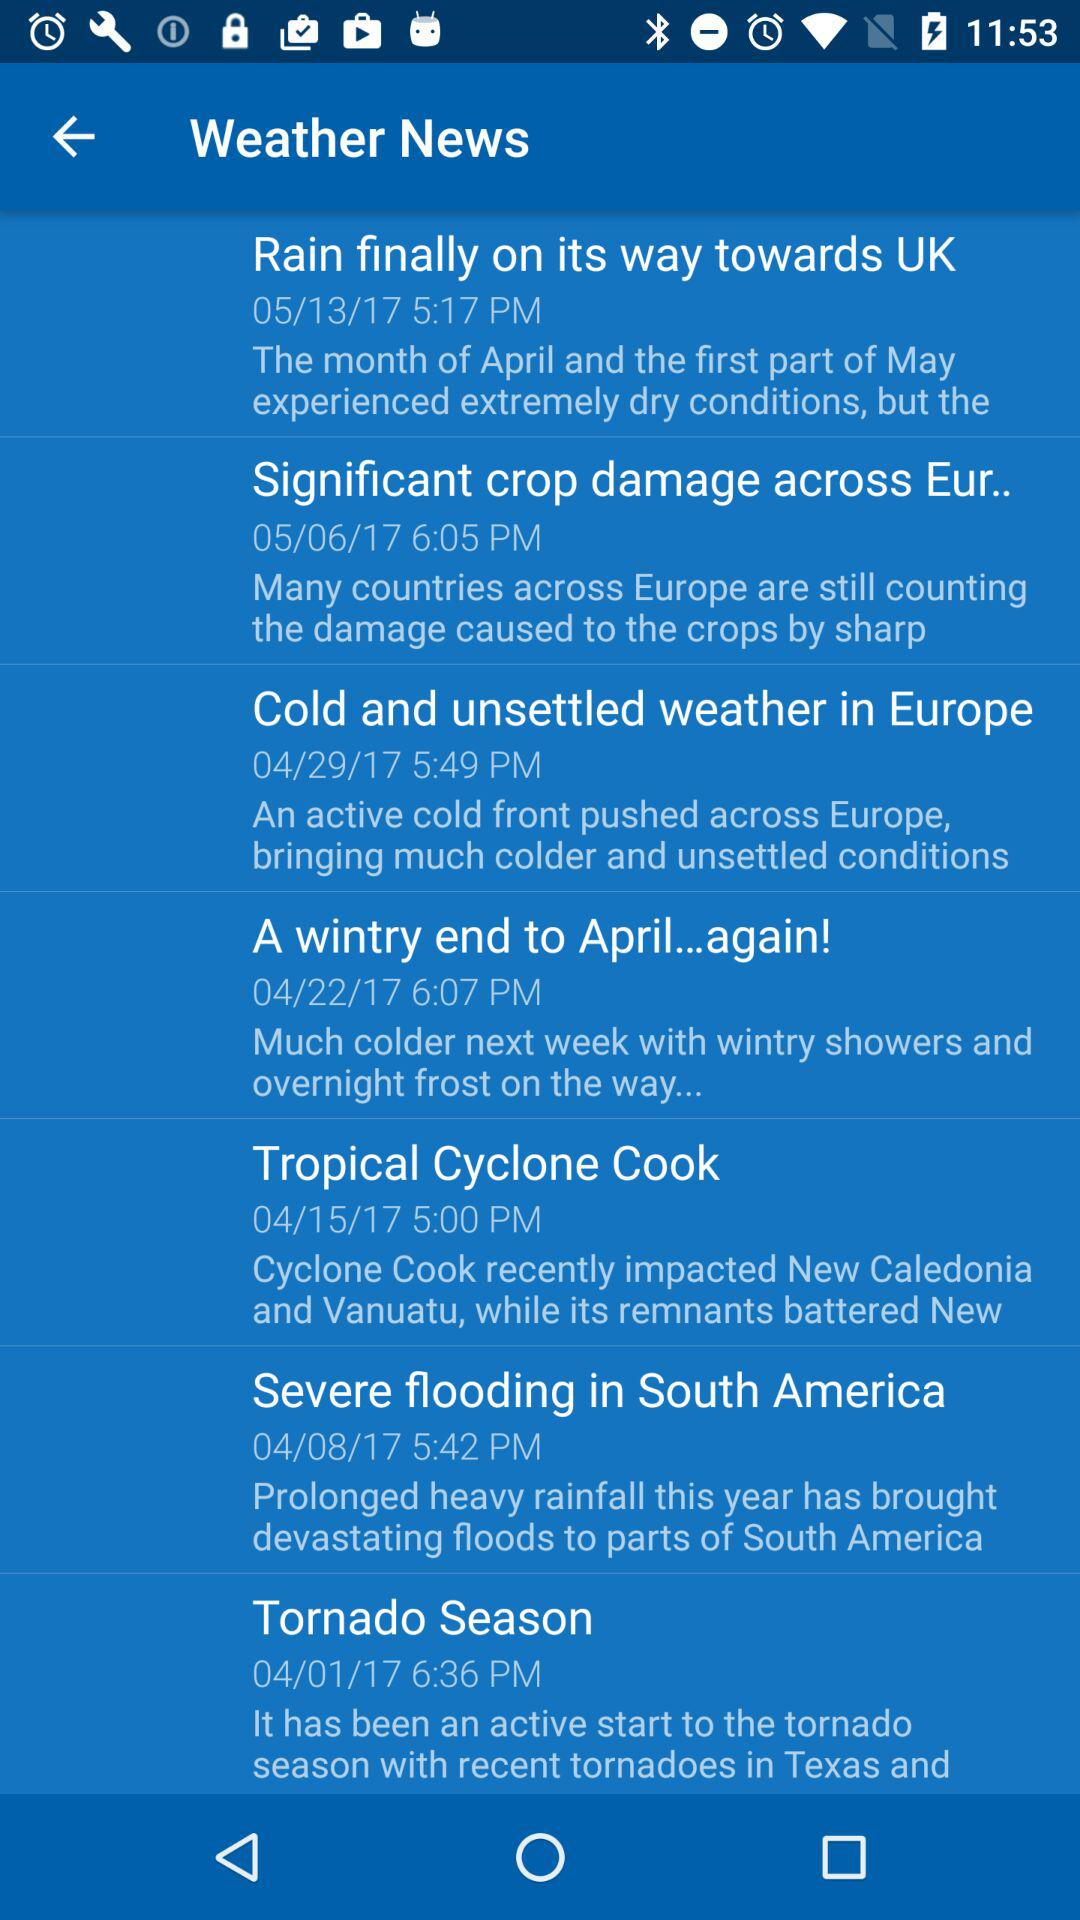Who posted the "Tropical Cyclone Cook" article?
When the provided information is insufficient, respond with <no answer>. <no answer> 